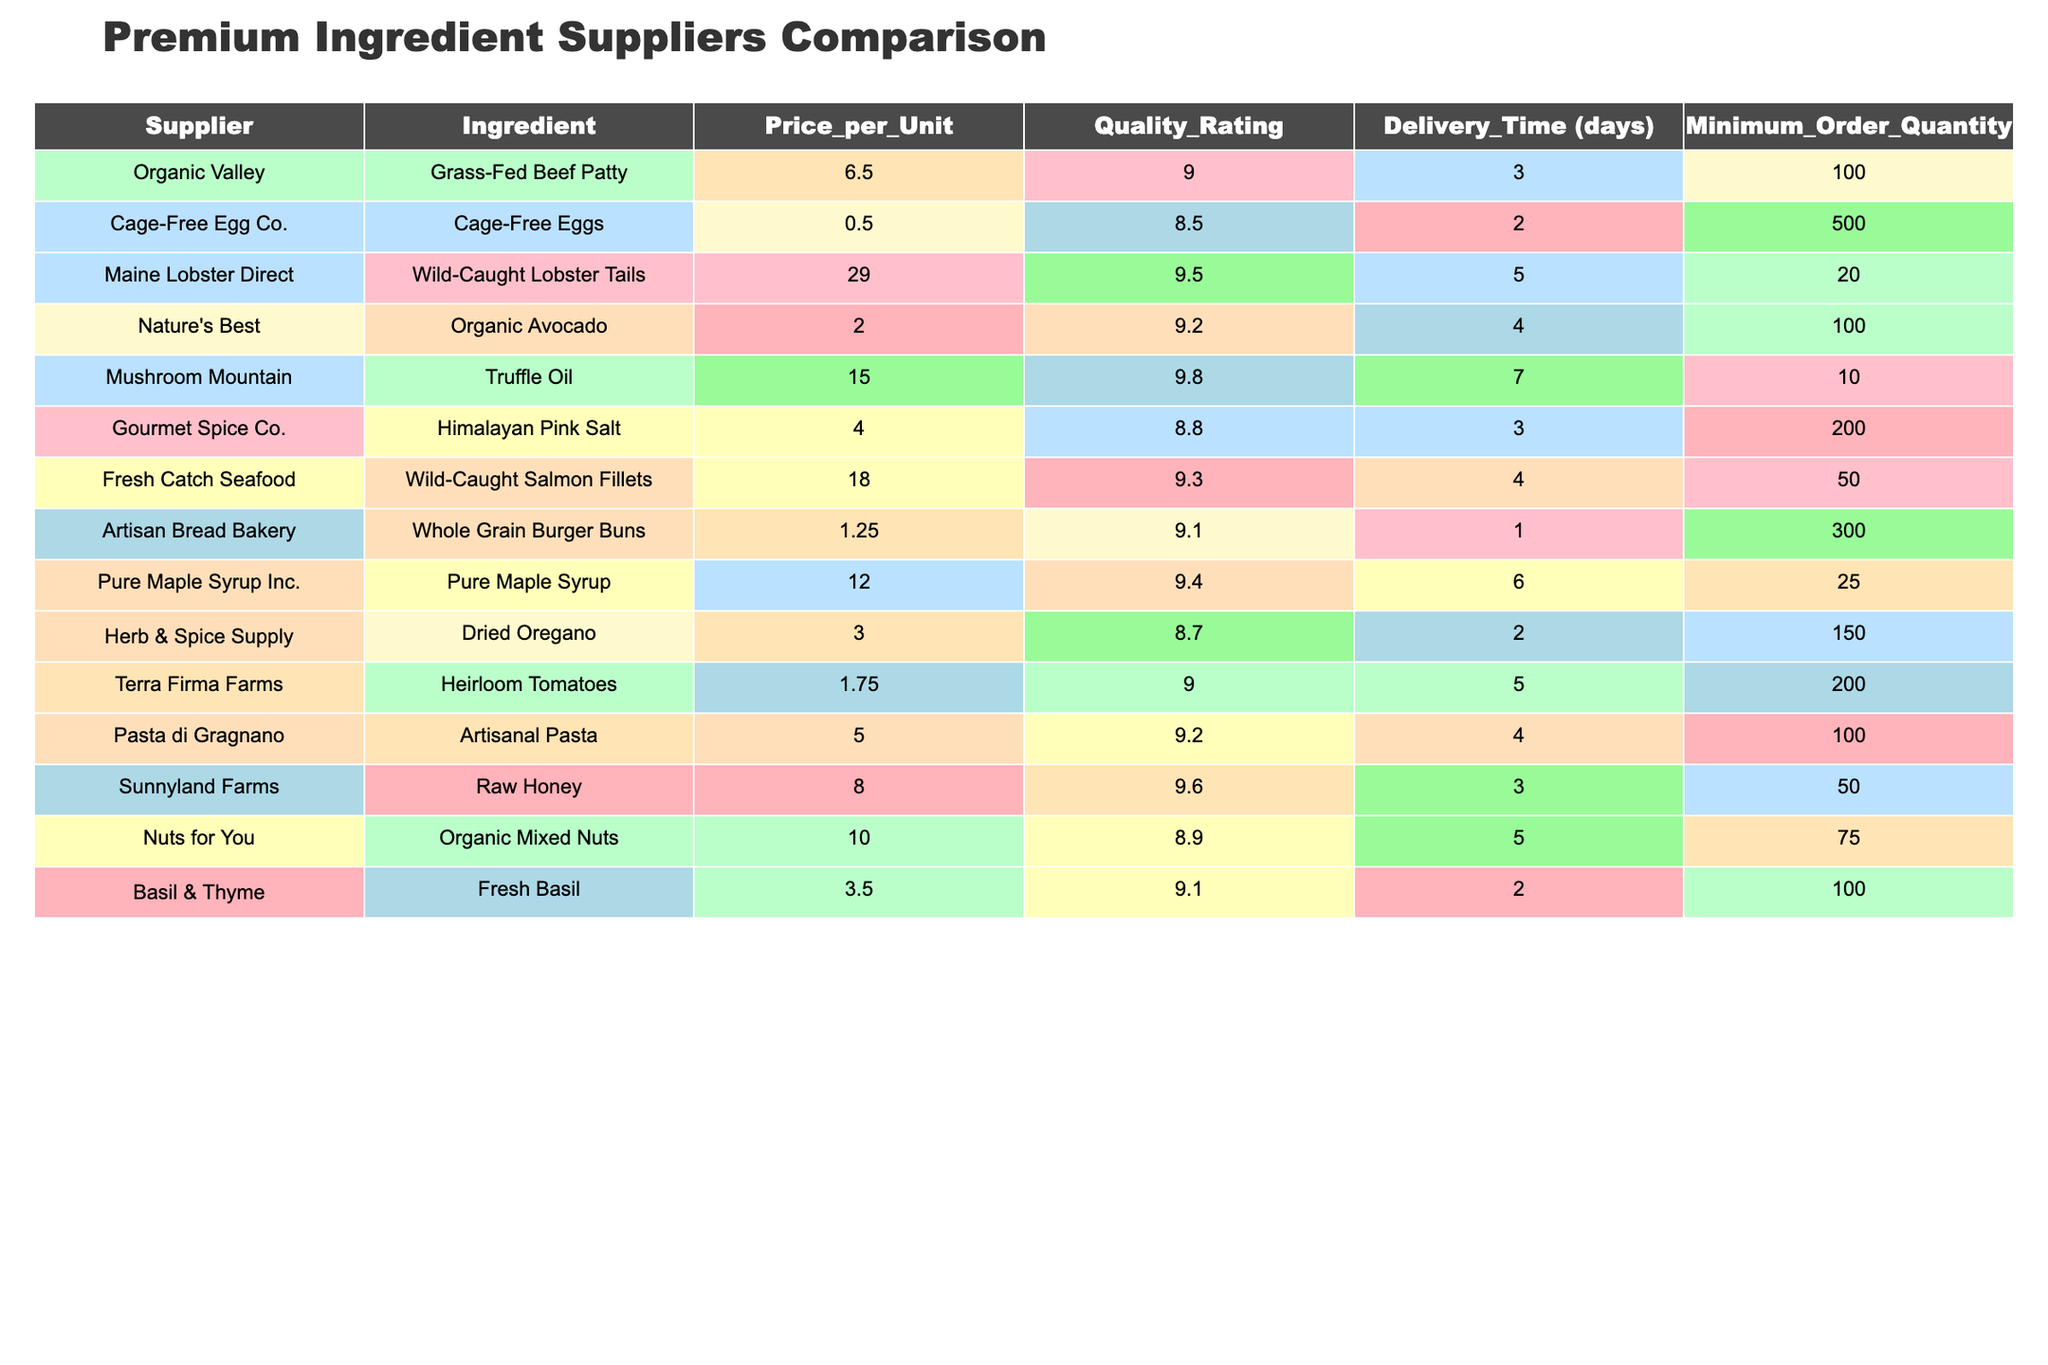What is the price per unit of Wild-Caught Salmon Fillets? The table lists the price per unit for each ingredient. Looking at the row for Wild-Caught Salmon Fillets, the price is 18.00.
Answer: 18.00 Which supplier offers the ingredient with the highest quality rating? The quality ratings are listed for each ingredient. The highest quality rating in the table is 9.8, provided by Mushroom Mountain for Truffle Oil.
Answer: Mushroom Mountain (Truffle Oil) How many days does it take for delivery from Cage-Free Egg Co.? The delivery time for each supplier is provided in the table. The delivery time for Cage-Free Egg Co. is 2 days.
Answer: 2 days Calculate the average price per unit of the ingredients listed in the table. First, add up all the prices: (6.50 + 0.50 + 29.00 + 2.00 + 15.00 + 4.00 + 18.00 + 1.25 + 12.00 + 3.00 + 1.75 + 5.00 + 8.00 + 10.00 + 3.50) = 115.00. There are 15 ingredients, so divide 115.00 by 15, which equals approximately 7.67.
Answer: 7.67 Is there an ingredient with a minimum order quantity below 50? Looking at the Minimum Order Quantity for each ingredient, the only one below 50 is Maine Lobster Direct with a minimum order of 20 for Lobster Tails.
Answer: Yes What is the difference in quality rating between Organic Avocado and Wild-Caught Lobster Tails? The quality rating for Organic Avocado is 9.2 and for Wild-Caught Lobster Tails is 9.5. To find the difference, subtract: 9.5 - 9.2 = 0.3.
Answer: 0.3 Which ingredient has the longest delivery time, and how long is it? From the delivery times listed, Mushroom Mountain's Truffle Oil has the longest delivery time of 7 days.
Answer: Truffle Oil, 7 days How many suppliers provide ingredients that have a quality rating of 9.0 or above? I will count the entries in the table with a quality rating of 9.0 or higher. The suppliers with ratings above or equal to 9.0 are Organic Valley, Maine Lobster Direct, Nature's Best, Mushroom Mountain, Fresh Catch Seafood, Artisan Bread Bakery, Pure Maple Syrup Inc., Terra Firma Farms, and Sunnyland Farms. This sums up to 9 suppliers.
Answer: 9 suppliers What is the minimum order quantity for Organic Mixed Nuts? The table indicates that the minimum order quantity for Organic Mixed Nuts is 75.
Answer: 75 If the price of Heirloom Tomatoes is reduced by 50%, what will the new price be? Currently, Heirloom Tomatoes are priced at 1.75. Halving this amount: 1.75 / 2 = 0.875.
Answer: 0.875 Which supplier has the fastest delivery time, and for which ingredient? The table shows the delivery times, with Cage-Free Egg Co. having the shortest at 2 days for Cage-Free Eggs.
Answer: Cage-Free Egg Co. for Cage-Free Eggs, 2 days 